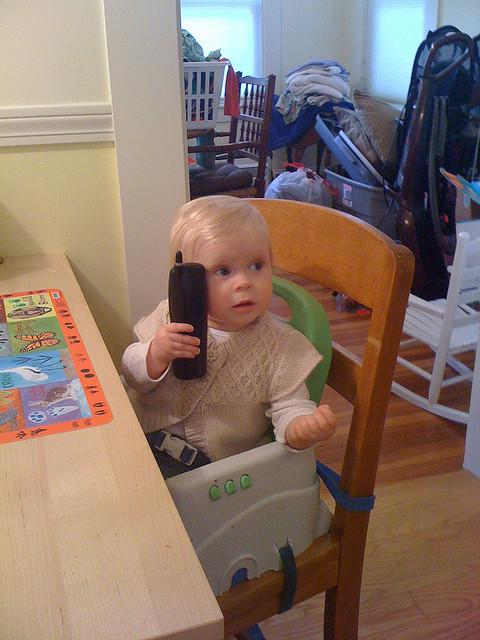Whos number did the child dial? Please explain your reasoning. no ones. The child can't dial numbers. 